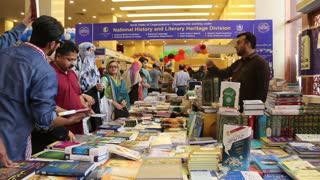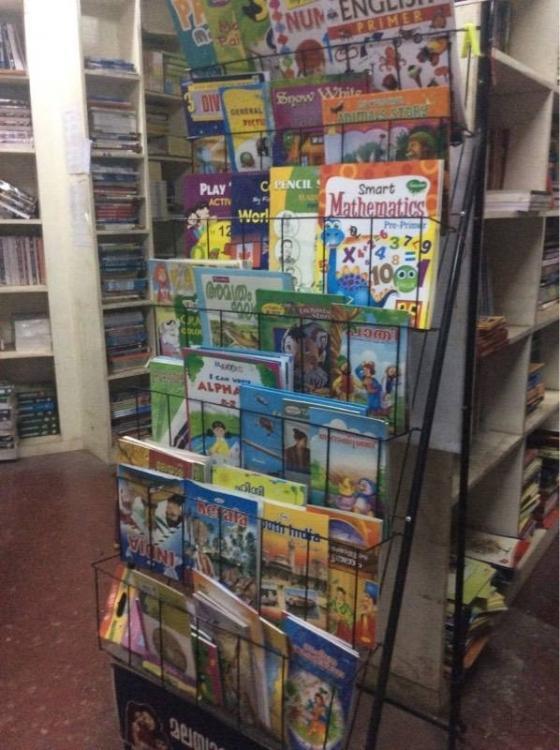The first image is the image on the left, the second image is the image on the right. Considering the images on both sides, is "All images contain books stored on book shelves." valid? Answer yes or no. No. 